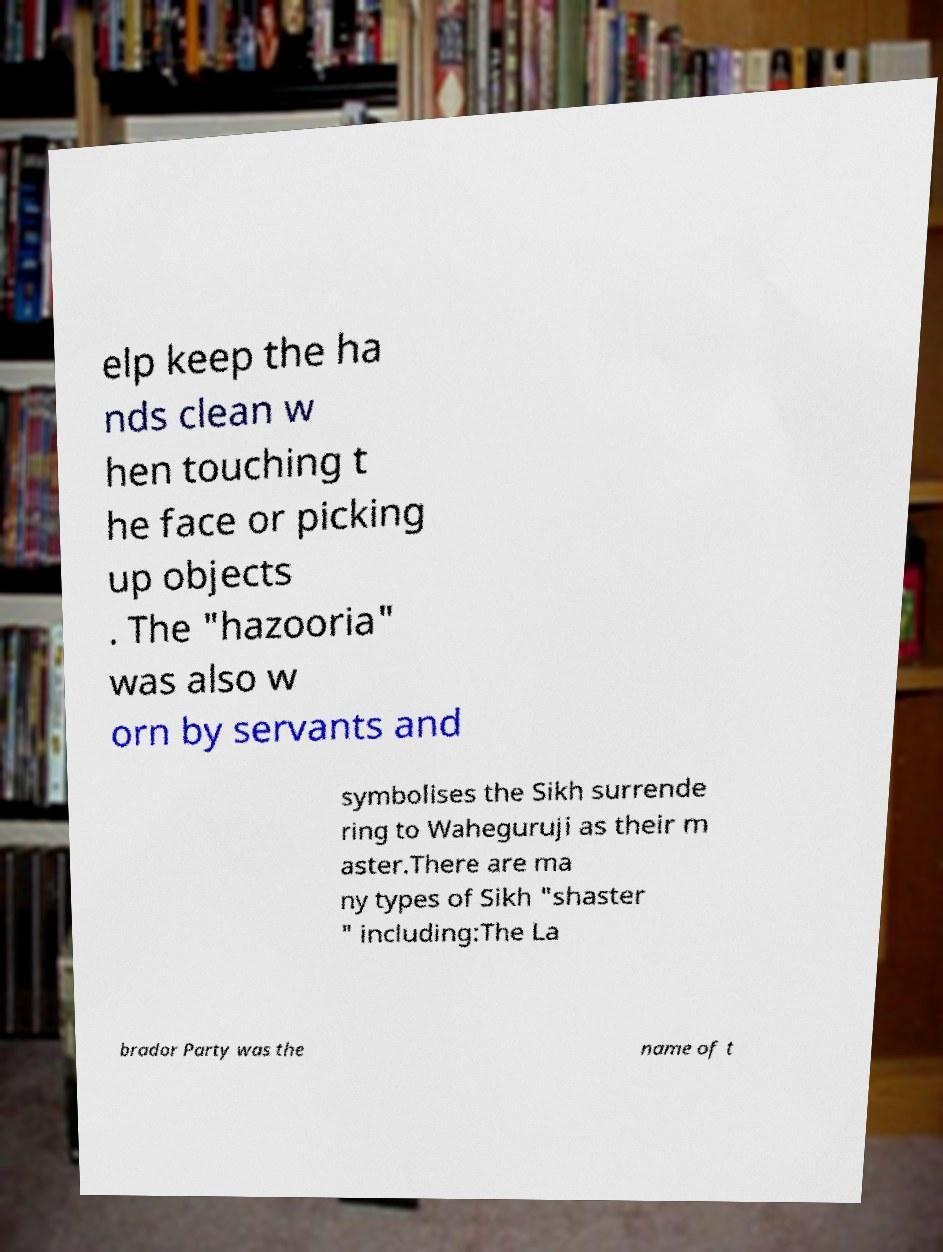Please identify and transcribe the text found in this image. elp keep the ha nds clean w hen touching t he face or picking up objects . The "hazooria" was also w orn by servants and symbolises the Sikh surrende ring to Waheguruji as their m aster.There are ma ny types of Sikh "shaster " including:The La brador Party was the name of t 